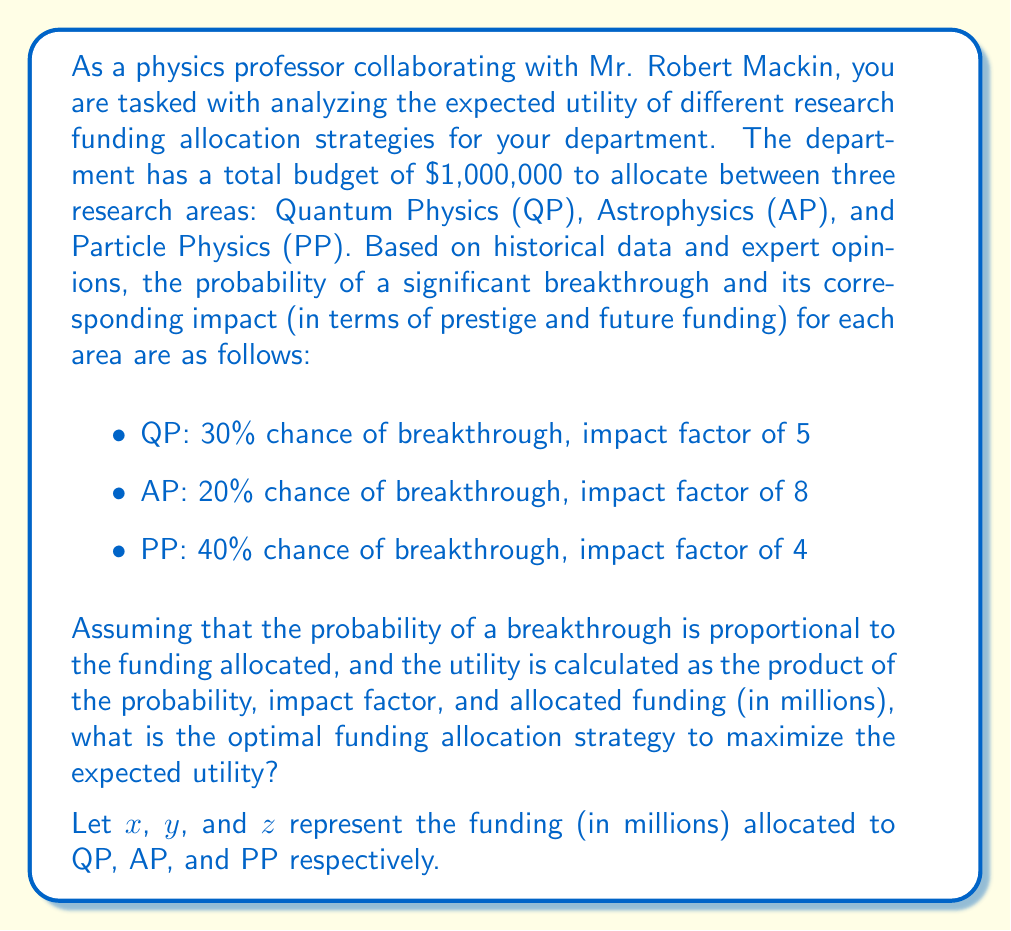Help me with this question. To solve this problem, we need to maximize the expected utility function subject to the constraint that the total funding is $1 million. Let's approach this step-by-step:

1) First, let's define the expected utility function:

   $$U(x,y,z) = 0.3 \cdot 5 \cdot x + 0.2 \cdot 8 \cdot y + 0.4 \cdot 4 \cdot z$$

2) We have the constraint:

   $$x + y + z = 1$$

3) We can use the method of Lagrange multipliers to maximize U subject to this constraint. Let's define the Lagrangian:

   $$L(x,y,z,\lambda) = 0.3 \cdot 5 \cdot x + 0.2 \cdot 8 \cdot y + 0.4 \cdot 4 \cdot z - \lambda(x + y + z - 1)$$

4) Now, we set the partial derivatives equal to zero:

   $$\frac{\partial L}{\partial x} = 1.5 - \lambda = 0$$
   $$\frac{\partial L}{\partial y} = 1.6 - \lambda = 0$$
   $$\frac{\partial L}{\partial z} = 1.6 - \lambda = 0$$
   $$\frac{\partial L}{\partial \lambda} = x + y + z - 1 = 0$$

5) From these equations, we can see that:

   $$1.5 = 1.6 = 1.6 = \lambda$$

   This implies that $x = 0$ (since its coefficient is less than the others), and $y = z$.

6) Substituting into the constraint equation:

   $$0 + y + z = 1$$
   $$2y = 1$$
   $$y = 0.5$$

7) Therefore, the optimal allocation is:

   QP (x): $0
   AP (y): $0.5 million
   PP (z): $0.5 million

8) We can verify that this maximizes the expected utility:

   $$U(0, 0.5, 0.5) = 0.3 \cdot 5 \cdot 0 + 0.2 \cdot 8 \cdot 0.5 + 0.4 \cdot 4 \cdot 0.5 = 1.6$$

   This is indeed the maximum value of U given the constraints.
Answer: The optimal funding allocation strategy to maximize the expected utility is:

Quantum Physics: $0
Astrophysics: $500,000
Particle Physics: $500,000

This allocation yields a maximum expected utility of 1.6. 